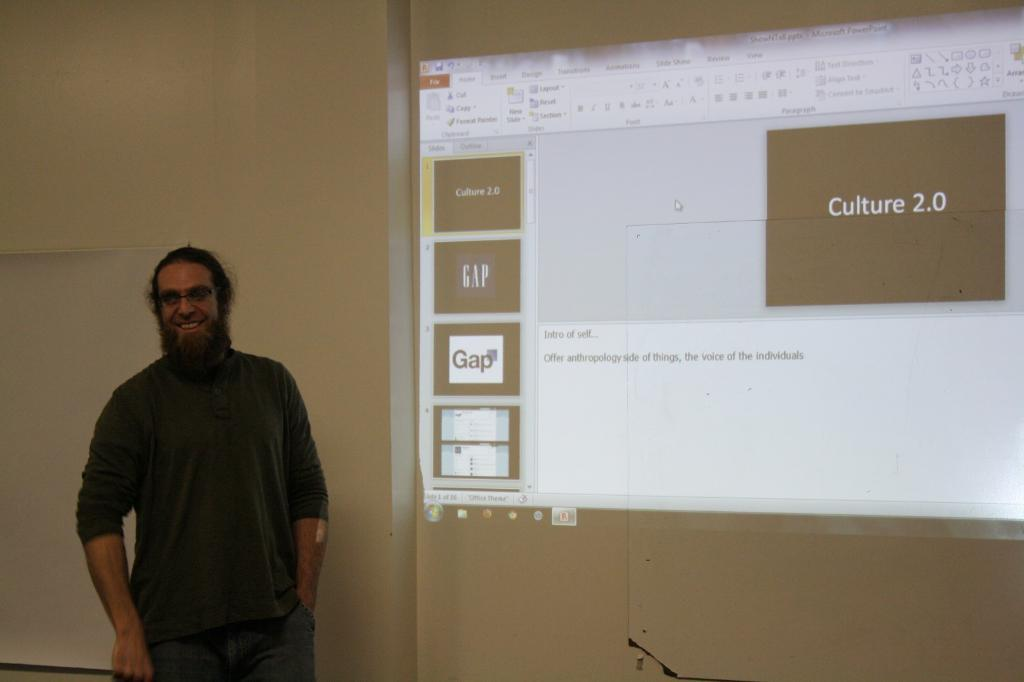Who is present in the image? There is a man in the image. What is the man doing in the image? The man is standing in the image. What is the man's facial expression in the image? The man is smiling in the image. What color is the t-shirt the man is wearing? The man is wearing a grey color t-shirt. What can be seen behind the man in the image? There is a screen behind the man in the image. What type of care does the man provide for the snow in the image? There is no snow present in the image, so the man cannot provide care for it. 